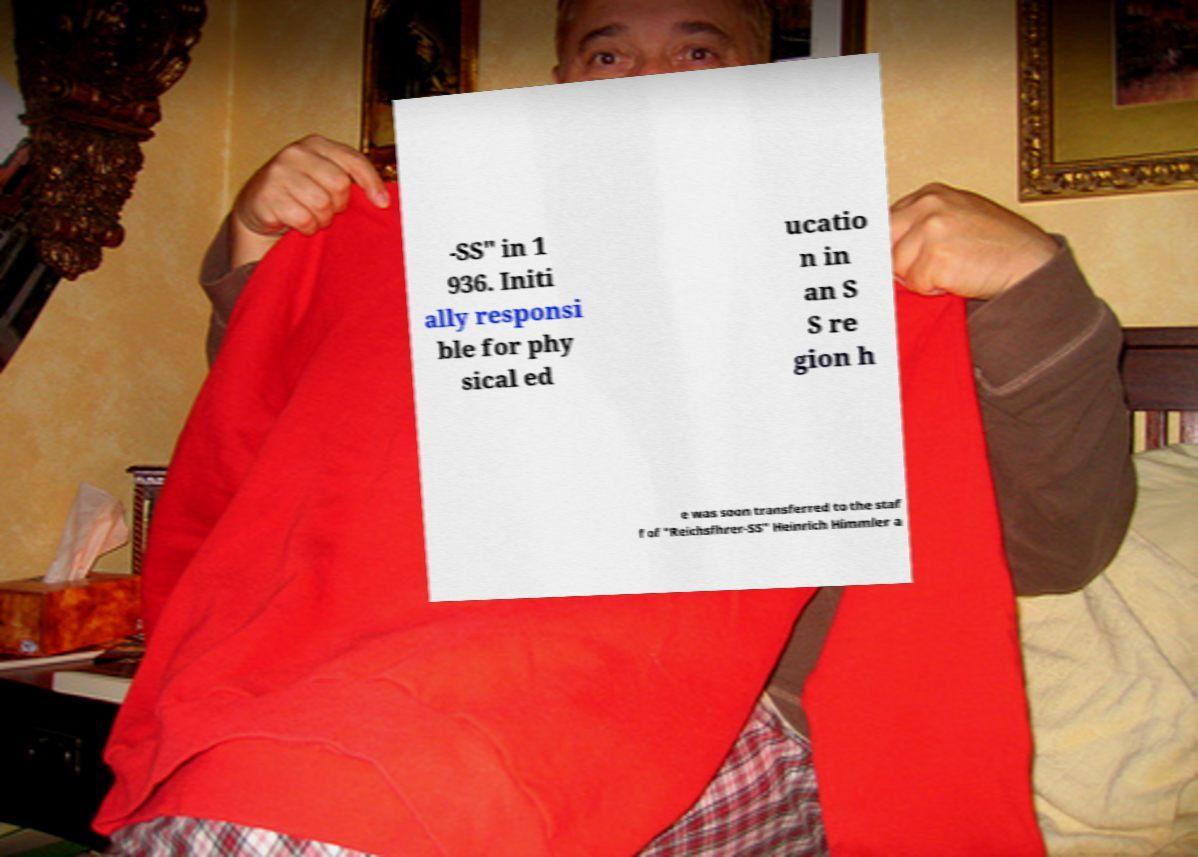Please read and relay the text visible in this image. What does it say? -SS" in 1 936. Initi ally responsi ble for phy sical ed ucatio n in an S S re gion h e was soon transferred to the staf f of "Reichsfhrer-SS" Heinrich Himmler a 